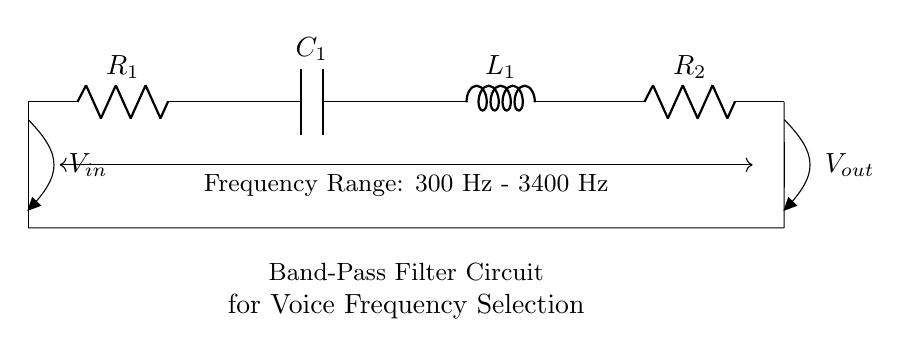What are the components in this circuit? The circuit contains two resistors (R1 and R2), one capacitor (C1), and one inductor (L1). These are standard components typically used to create a band-pass filter.
Answer: Resistors, capacitor, inductor What is the frequency range of this filter? The frequency range marked in the circuit diagram indicates that it is designed for frequencies between 300 Hz and 3400 Hz. This is important for filtering voice frequencies in telephone systems.
Answer: 300 Hz - 3400 Hz What is the purpose of this circuit? This circuit is designed as a band-pass filter, which allows specific frequency ranges to pass through while attenuating others. In this case, it selects voice frequencies suitable for transmission over telephone lines.
Answer: Band-pass filter for voice frequency selection How many resistors are in the circuit? The circuit has two resistors, identified as R1 and R2, which affect the overall impedance and frequency response of the filter.
Answer: 2 What type of filter is being represented? This circuit is a band-pass filter, as indicated by the specific components and connections that allow certain frequencies to pass while blocking others.
Answer: Band-pass filter What role does the inductor play in this circuit? The inductor (L1) in a band-pass filter helps to block high and low frequencies while allowing a specific range to pass through; it is crucial for the filter’s frequency response along with the capacitor and resistors.
Answer: Blocking unwanted frequencies Where is the input voltage connected? The input voltage (Vin) is connected at the left side of the circuit, designated at point 0, allowing the input signal to enter the filter.
Answer: Left side of the circuit 